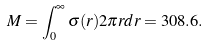Convert formula to latex. <formula><loc_0><loc_0><loc_500><loc_500>M = \int _ { 0 } ^ { \infty } \sigma ( r ) 2 \pi r d r = 3 0 8 . 6 .</formula> 